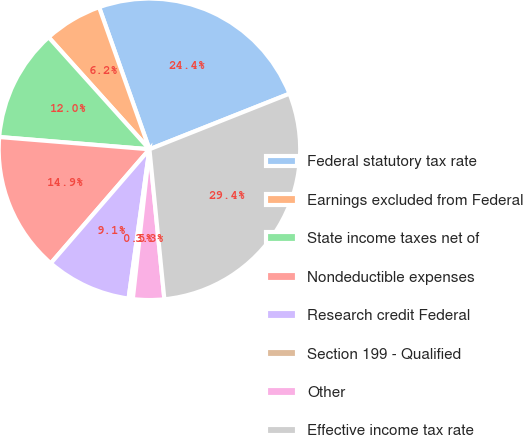<chart> <loc_0><loc_0><loc_500><loc_500><pie_chart><fcel>Federal statutory tax rate<fcel>Earnings excluded from Federal<fcel>State income taxes net of<fcel>Nondeductible expenses<fcel>Research credit Federal<fcel>Section 199 - Qualified<fcel>Other<fcel>Effective income tax rate<nl><fcel>24.4%<fcel>6.24%<fcel>12.04%<fcel>14.94%<fcel>9.14%<fcel>0.45%<fcel>3.34%<fcel>29.43%<nl></chart> 